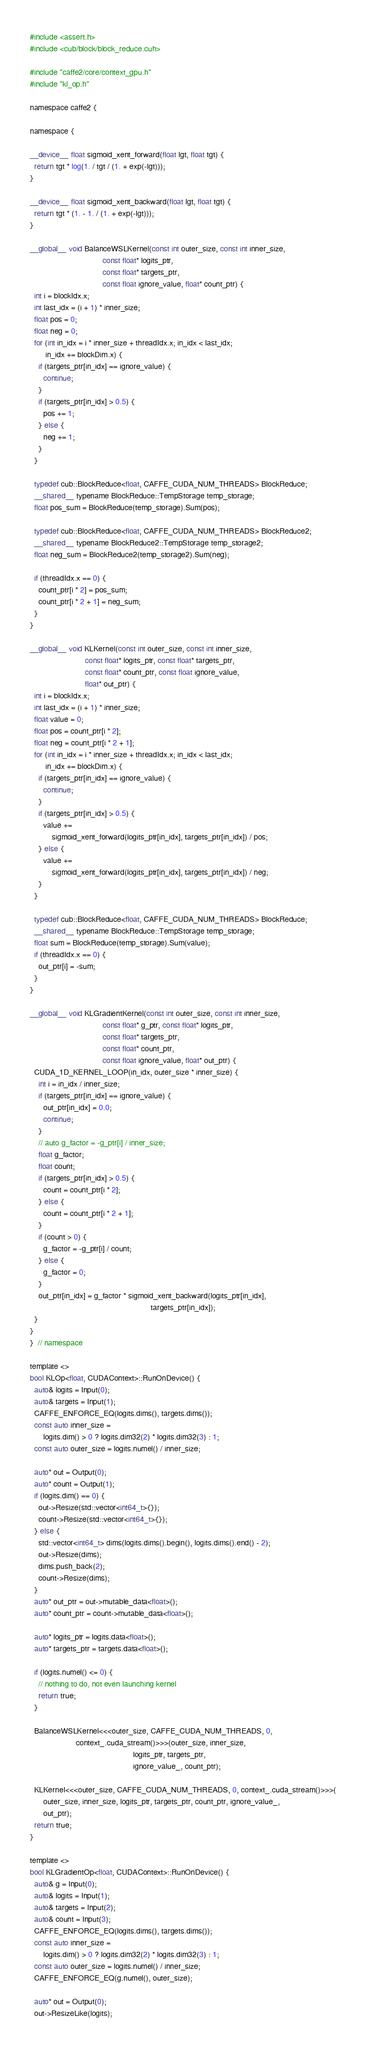<code> <loc_0><loc_0><loc_500><loc_500><_Cuda_>#include <assert.h>
#include <cub/block/block_reduce.cuh>

#include "caffe2/core/context_gpu.h"
#include "kl_op.h"

namespace caffe2 {

namespace {

__device__ float sigmoid_xent_forward(float lgt, float tgt) {
  return tgt * log(1. / tgt / (1. + exp(-lgt)));
}

__device__ float sigmoid_xent_backward(float lgt, float tgt) {
  return tgt * (1. - 1. / (1. + exp(-lgt)));
}

__global__ void BalanceWSLKernel(const int outer_size, const int inner_size,
                                 const float* logits_ptr,
                                 const float* targets_ptr,
                                 const float ignore_value, float* count_ptr) {
  int i = blockIdx.x;
  int last_idx = (i + 1) * inner_size;
  float pos = 0;
  float neg = 0;
  for (int in_idx = i * inner_size + threadIdx.x; in_idx < last_idx;
       in_idx += blockDim.x) {
    if (targets_ptr[in_idx] == ignore_value) {
      continue;
    }
    if (targets_ptr[in_idx] > 0.5) {
      pos += 1;
    } else {
      neg += 1;
    }
  }

  typedef cub::BlockReduce<float, CAFFE_CUDA_NUM_THREADS> BlockReduce;
  __shared__ typename BlockReduce::TempStorage temp_storage;
  float pos_sum = BlockReduce(temp_storage).Sum(pos);

  typedef cub::BlockReduce<float, CAFFE_CUDA_NUM_THREADS> BlockReduce2;
  __shared__ typename BlockReduce2::TempStorage temp_storage2;
  float neg_sum = BlockReduce2(temp_storage2).Sum(neg);

  if (threadIdx.x == 0) {
    count_ptr[i * 2] = pos_sum;
    count_ptr[i * 2 + 1] = neg_sum;
  }
}

__global__ void KLKernel(const int outer_size, const int inner_size,
                         const float* logits_ptr, const float* targets_ptr,
                         const float* count_ptr, const float ignore_value,
                         float* out_ptr) {
  int i = blockIdx.x;
  int last_idx = (i + 1) * inner_size;
  float value = 0;
  float pos = count_ptr[i * 2];
  float neg = count_ptr[i * 2 + 1];
  for (int in_idx = i * inner_size + threadIdx.x; in_idx < last_idx;
       in_idx += blockDim.x) {
    if (targets_ptr[in_idx] == ignore_value) {
      continue;
    }
    if (targets_ptr[in_idx] > 0.5) {
      value +=
          sigmoid_xent_forward(logits_ptr[in_idx], targets_ptr[in_idx]) / pos;
    } else {
      value +=
          sigmoid_xent_forward(logits_ptr[in_idx], targets_ptr[in_idx]) / neg;
    }
  }

  typedef cub::BlockReduce<float, CAFFE_CUDA_NUM_THREADS> BlockReduce;
  __shared__ typename BlockReduce::TempStorage temp_storage;
  float sum = BlockReduce(temp_storage).Sum(value);
  if (threadIdx.x == 0) {
    out_ptr[i] = -sum;
  }
}

__global__ void KLGradientKernel(const int outer_size, const int inner_size,
                                 const float* g_ptr, const float* logits_ptr,
                                 const float* targets_ptr,
                                 const float* count_ptr,
                                 const float ignore_value, float* out_ptr) {
  CUDA_1D_KERNEL_LOOP(in_idx, outer_size * inner_size) {
    int i = in_idx / inner_size;
    if (targets_ptr[in_idx] == ignore_value) {
      out_ptr[in_idx] = 0.0;
      continue;
    }
    // auto g_factor = -g_ptr[i] / inner_size;
    float g_factor;
    float count;
    if (targets_ptr[in_idx] > 0.5) {
      count = count_ptr[i * 2];
    } else {
      count = count_ptr[i * 2 + 1];
    }
    if (count > 0) {
      g_factor = -g_ptr[i] / count;
    } else {
      g_factor = 0;
    }
    out_ptr[in_idx] = g_factor * sigmoid_xent_backward(logits_ptr[in_idx],
                                                       targets_ptr[in_idx]);
  }
}
}  // namespace

template <>
bool KLOp<float, CUDAContext>::RunOnDevice() {
  auto& logits = Input(0);
  auto& targets = Input(1);
  CAFFE_ENFORCE_EQ(logits.dims(), targets.dims());
  const auto inner_size =
      logits.dim() > 0 ? logits.dim32(2) * logits.dim32(3) : 1;
  const auto outer_size = logits.numel() / inner_size;

  auto* out = Output(0);
  auto* count = Output(1);
  if (logits.dim() == 0) {
    out->Resize(std::vector<int64_t>{});
    count->Resize(std::vector<int64_t>{});
  } else {
    std::vector<int64_t> dims(logits.dims().begin(), logits.dims().end() - 2);
    out->Resize(dims);
    dims.push_back(2);
    count->Resize(dims);
  }
  auto* out_ptr = out->mutable_data<float>();
  auto* count_ptr = count->mutable_data<float>();

  auto* logits_ptr = logits.data<float>();
  auto* targets_ptr = targets.data<float>();

  if (logits.numel() <= 0) {
    // nothing to do, not even launching kernel
    return true;
  }

  BalanceWSLKernel<<<outer_size, CAFFE_CUDA_NUM_THREADS, 0,
                     context_.cuda_stream()>>>(outer_size, inner_size,
                                               logits_ptr, targets_ptr,
                                               ignore_value_, count_ptr);

  KLKernel<<<outer_size, CAFFE_CUDA_NUM_THREADS, 0, context_.cuda_stream()>>>(
      outer_size, inner_size, logits_ptr, targets_ptr, count_ptr, ignore_value_,
      out_ptr);
  return true;
}

template <>
bool KLGradientOp<float, CUDAContext>::RunOnDevice() {
  auto& g = Input(0);
  auto& logits = Input(1);
  auto& targets = Input(2);
  auto& count = Input(3);
  CAFFE_ENFORCE_EQ(logits.dims(), targets.dims());
  const auto inner_size =
      logits.dim() > 0 ? logits.dim32(2) * logits.dim32(3) : 1;
  const auto outer_size = logits.numel() / inner_size;
  CAFFE_ENFORCE_EQ(g.numel(), outer_size);

  auto* out = Output(0);
  out->ResizeLike(logits);</code> 